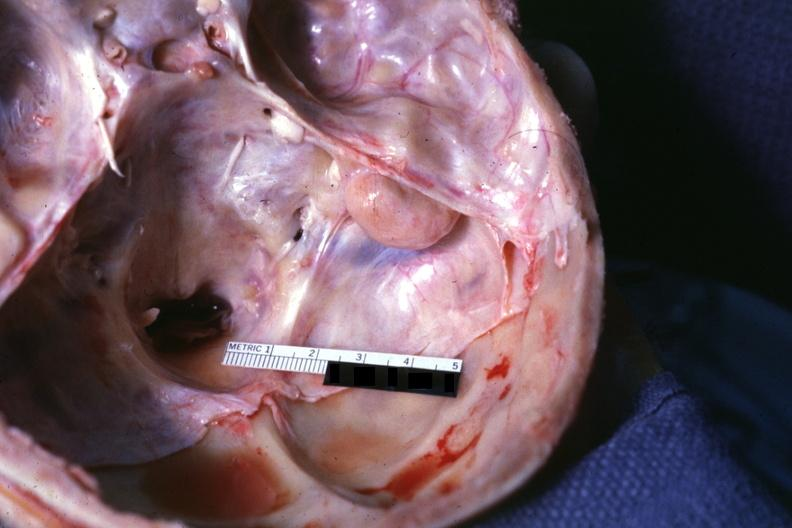s lesion seen on surface right petrous bone?
Answer the question using a single word or phrase. Yes 